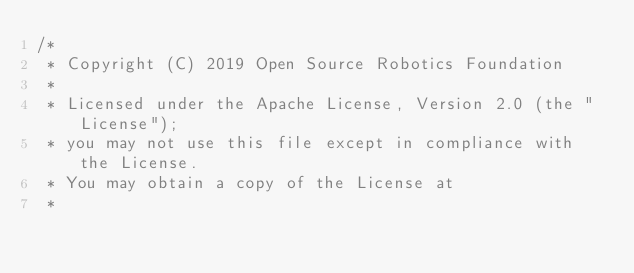<code> <loc_0><loc_0><loc_500><loc_500><_C++_>/*
 * Copyright (C) 2019 Open Source Robotics Foundation
 *
 * Licensed under the Apache License, Version 2.0 (the "License");
 * you may not use this file except in compliance with the License.
 * You may obtain a copy of the License at
 *</code> 